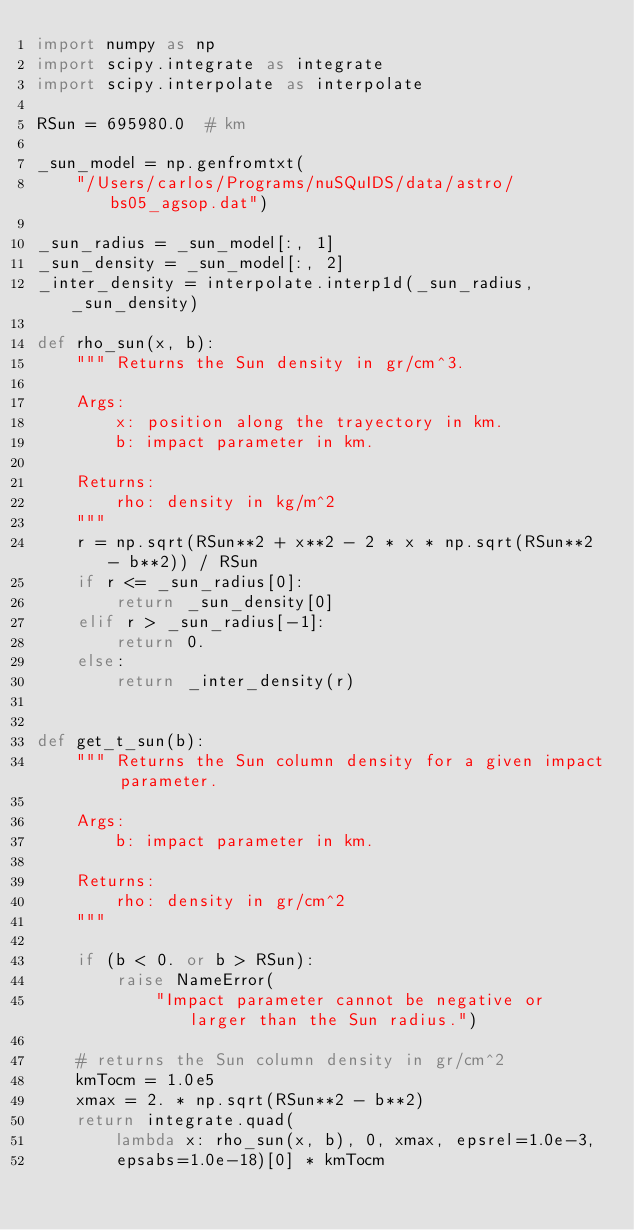<code> <loc_0><loc_0><loc_500><loc_500><_Python_>import numpy as np
import scipy.integrate as integrate
import scipy.interpolate as interpolate

RSun = 695980.0  # km

_sun_model = np.genfromtxt(
    "/Users/carlos/Programs/nuSQuIDS/data/astro/bs05_agsop.dat")

_sun_radius = _sun_model[:, 1]
_sun_density = _sun_model[:, 2]
_inter_density = interpolate.interp1d(_sun_radius, _sun_density)

def rho_sun(x, b):
    """ Returns the Sun density in gr/cm^3.

    Args:
        x: position along the trayectory in km.
        b: impact parameter in km.

    Returns:
        rho: density in kg/m^2
    """
    r = np.sqrt(RSun**2 + x**2 - 2 * x * np.sqrt(RSun**2 - b**2)) / RSun
    if r <= _sun_radius[0]:
        return _sun_density[0]
    elif r > _sun_radius[-1]:
        return 0.
    else:
        return _inter_density(r)


def get_t_sun(b):
    """ Returns the Sun column density for a given impact parameter.

    Args:
        b: impact parameter in km.

    Returns:
        rho: density in gr/cm^2
    """

    if (b < 0. or b > RSun):
        raise NameError(
            "Impact parameter cannot be negative or larger than the Sun radius.")

    # returns the Sun column density in gr/cm^2
    kmTocm = 1.0e5
    xmax = 2. * np.sqrt(RSun**2 - b**2)
    return integrate.quad(
        lambda x: rho_sun(x, b), 0, xmax, epsrel=1.0e-3,
        epsabs=1.0e-18)[0] * kmTocm
</code> 